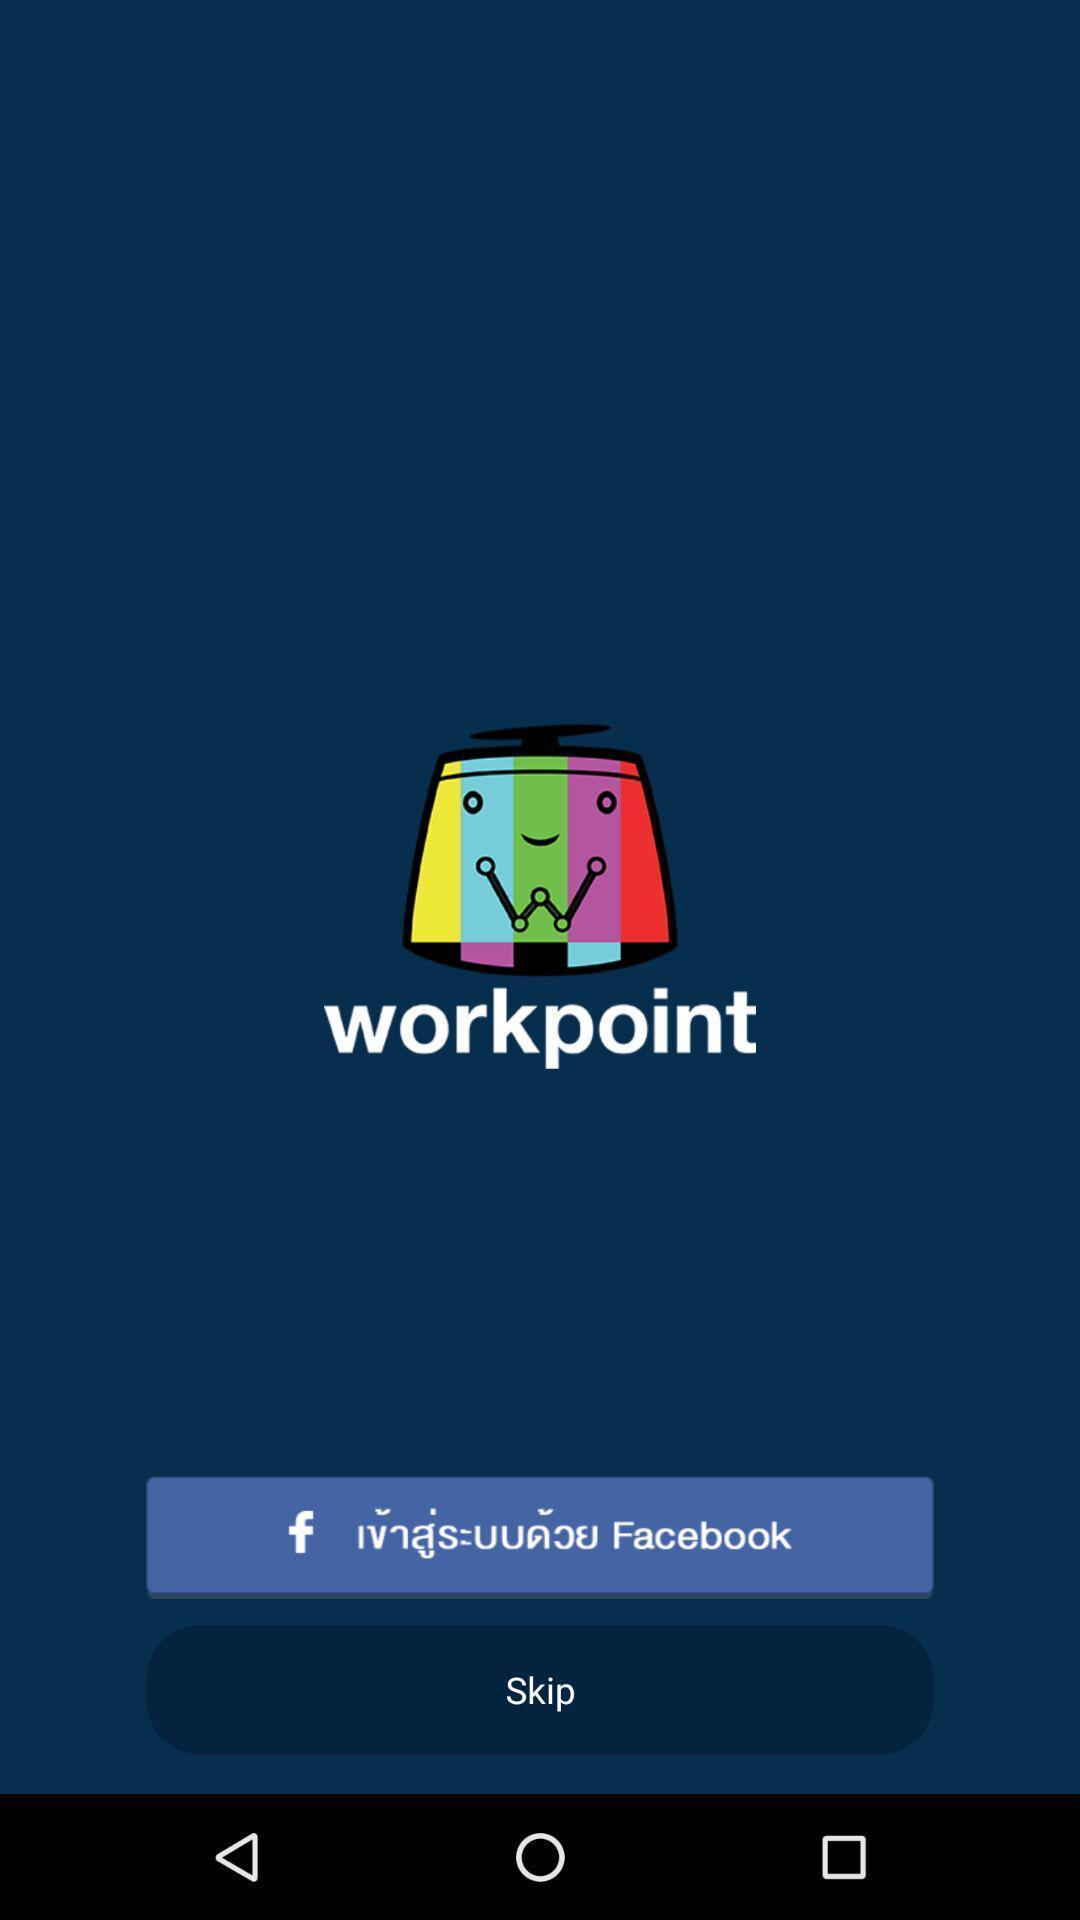Provide a description of this screenshot. Welcome page. 